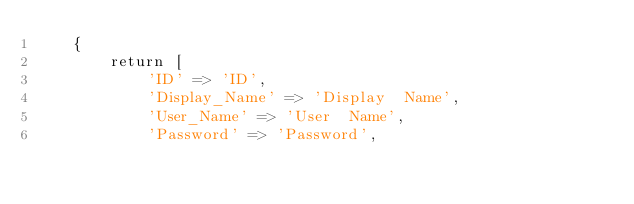Convert code to text. <code><loc_0><loc_0><loc_500><loc_500><_PHP_>    {
        return [
            'ID' => 'ID',
            'Display_Name' => 'Display  Name',
            'User_Name' => 'User  Name',
            'Password' => 'Password',</code> 